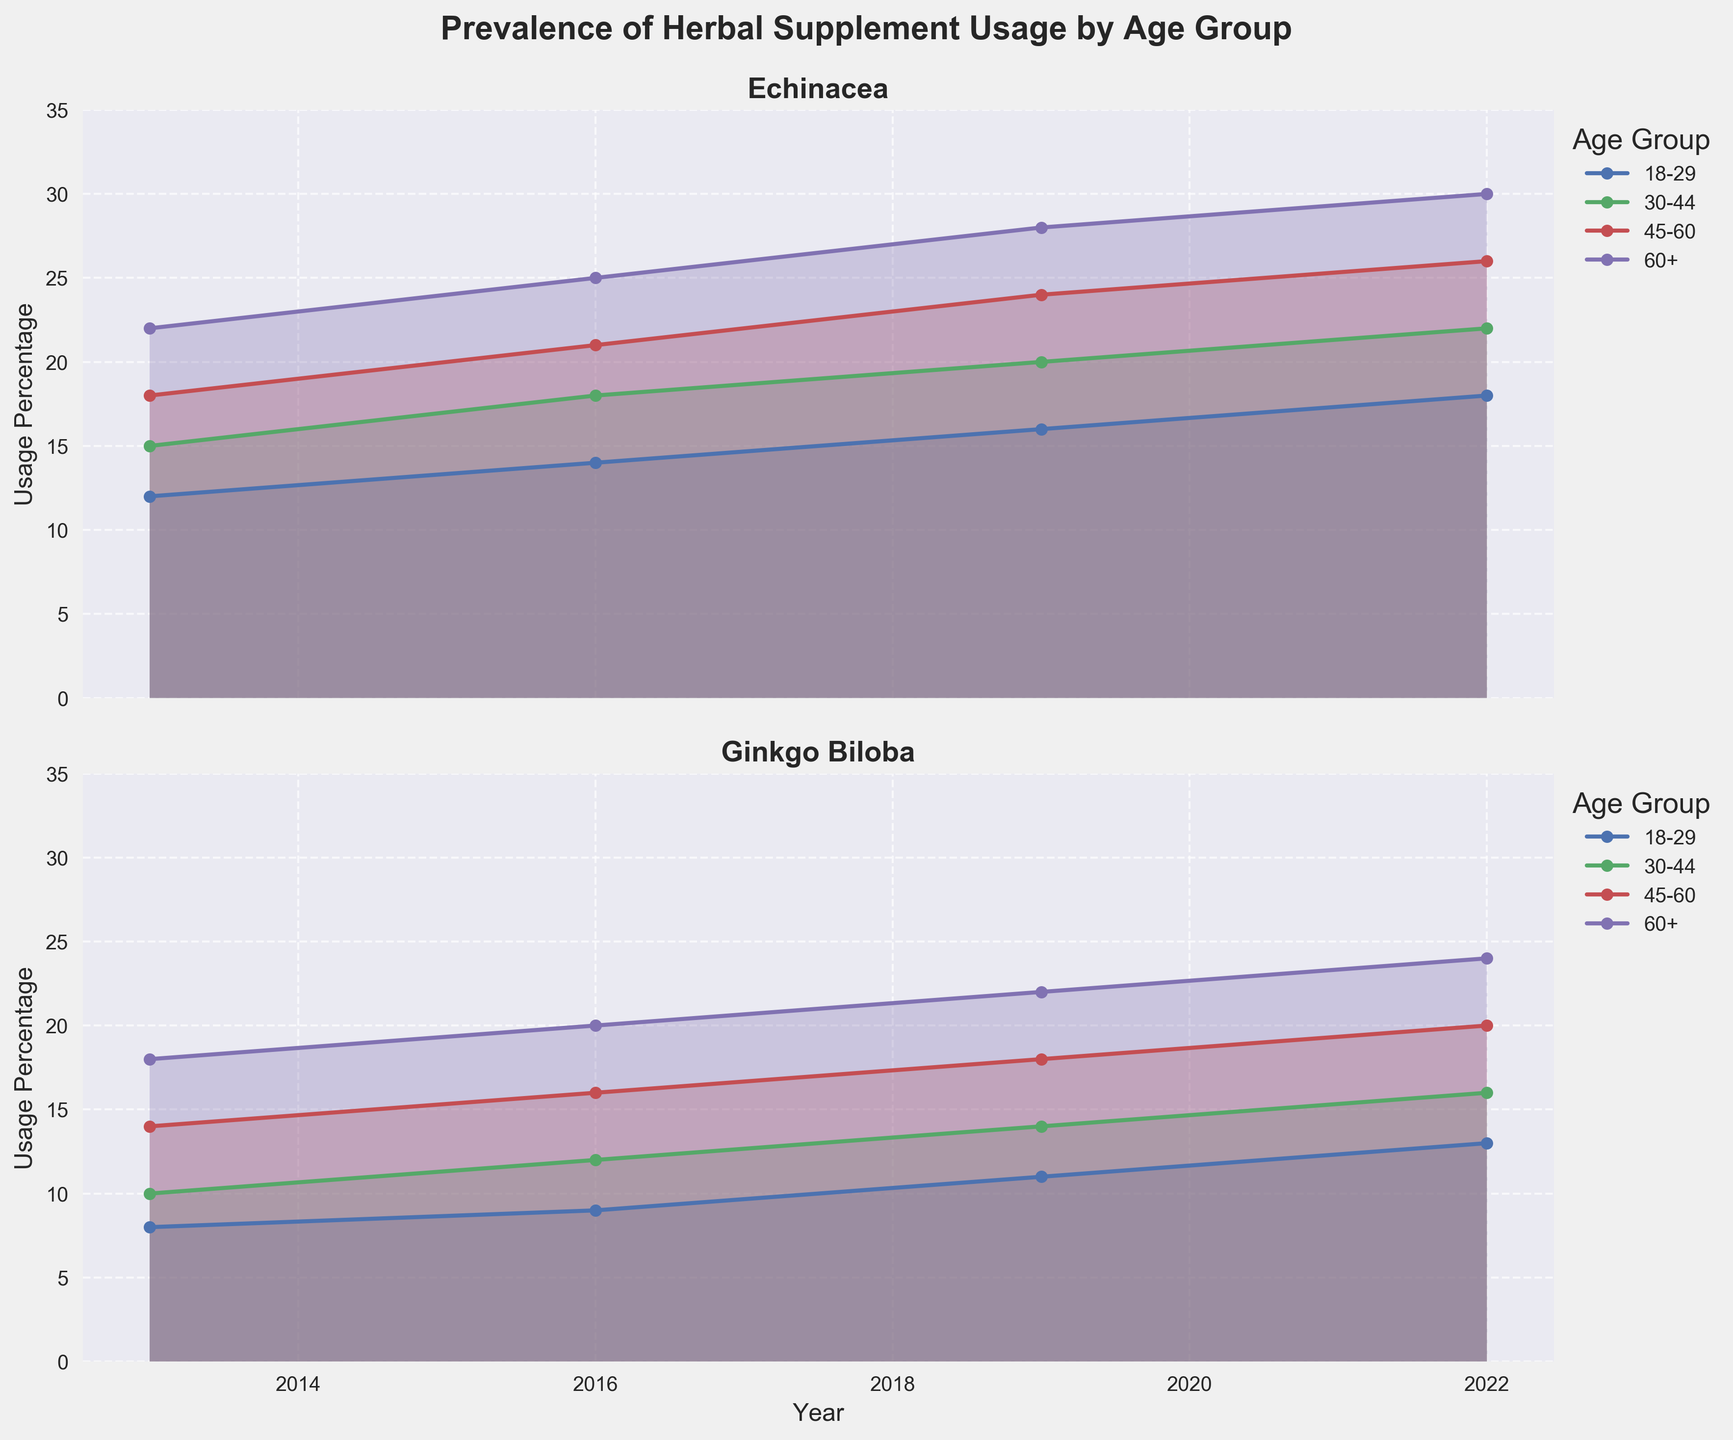What's the title of the figure? The title is usually at the top of the figure and can be directly read from there.
Answer: Prevalence of Herbal Supplement Usage by Age Group How many age groups are represented in the figure? Each unique age group is typically mentioned in the legend or labels. Count the distinct groups.
Answer: Four Which age group had the highest percentage of Echinacea usage in 2022? Look for the data points corresponding to 2022 for Echinacea and compare the values among the age groups. The highest value indicates the age group with the highest usage.
Answer: 60+ What trend do you see in the usage of Echinacea among the 18-29 age group over the years? Track the line corresponding to the 18-29 age group for Echinacea from 2013 to 2022 and describe the changes (increases/decreases/stable).
Answer: Increasing Compare the usage percentage of Ginkgo Biloba between the 30-44 and 60+ age groups in 2019. Which group had a higher usage? Identify and compare the respective values for both age groups in 2019.
Answer: 60+ What is the average usage percentage of Echinacea across all age groups in 2013? Add up the usage percentages of Echinacea for all age groups in 2013 and divide by the number of age groups (4).
Answer: 16.75 How did the usage of Ginkgo Biloba in the 45-60 age group change from 2013 to 2022? Track the line for the 45-60 age group for Ginkgo Biloba from 2013 to 2022 and describe any increases/decreases along the line.
Answer: Increased Discuss the overall trend in usage of herbal supplements among the 60+ age group from 2013 to 2022. Analyze the lines corresponding to the 60+ age group for both supplements from 2013 to 2022 and describe the general direction of the lines (upward/downward).
Answer: Increasing Which supplement had a steeper increase in usage among the 30-44 age group from 2016 to 2019? Compare the slopes of the lines for Echinacea and Ginkgo Biloba for the 30-44 age group between 2016 and 2019. The steeper slope indicates a faster increase.
Answer: Echinacea What is the difference in usage percentage of Echinacea between the 18-29 age group and the 60+ age group in 2016? Find the difference between the usage percentages of the two age groups for Echinacea in 2016.
Answer: 11 